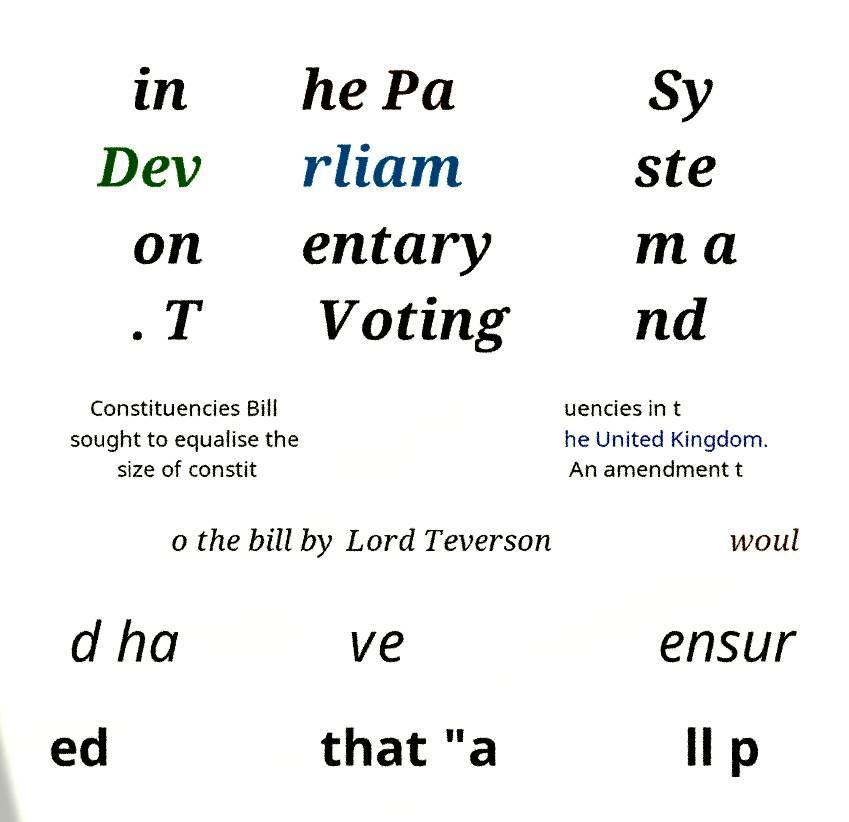Please read and relay the text visible in this image. What does it say? in Dev on . T he Pa rliam entary Voting Sy ste m a nd Constituencies Bill sought to equalise the size of constit uencies in t he United Kingdom. An amendment t o the bill by Lord Teverson woul d ha ve ensur ed that "a ll p 